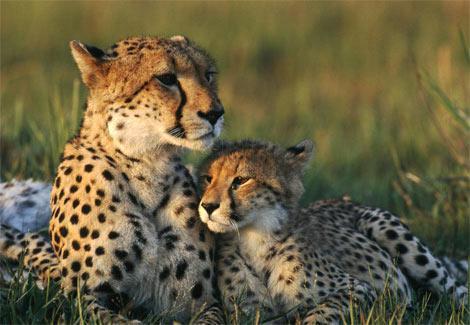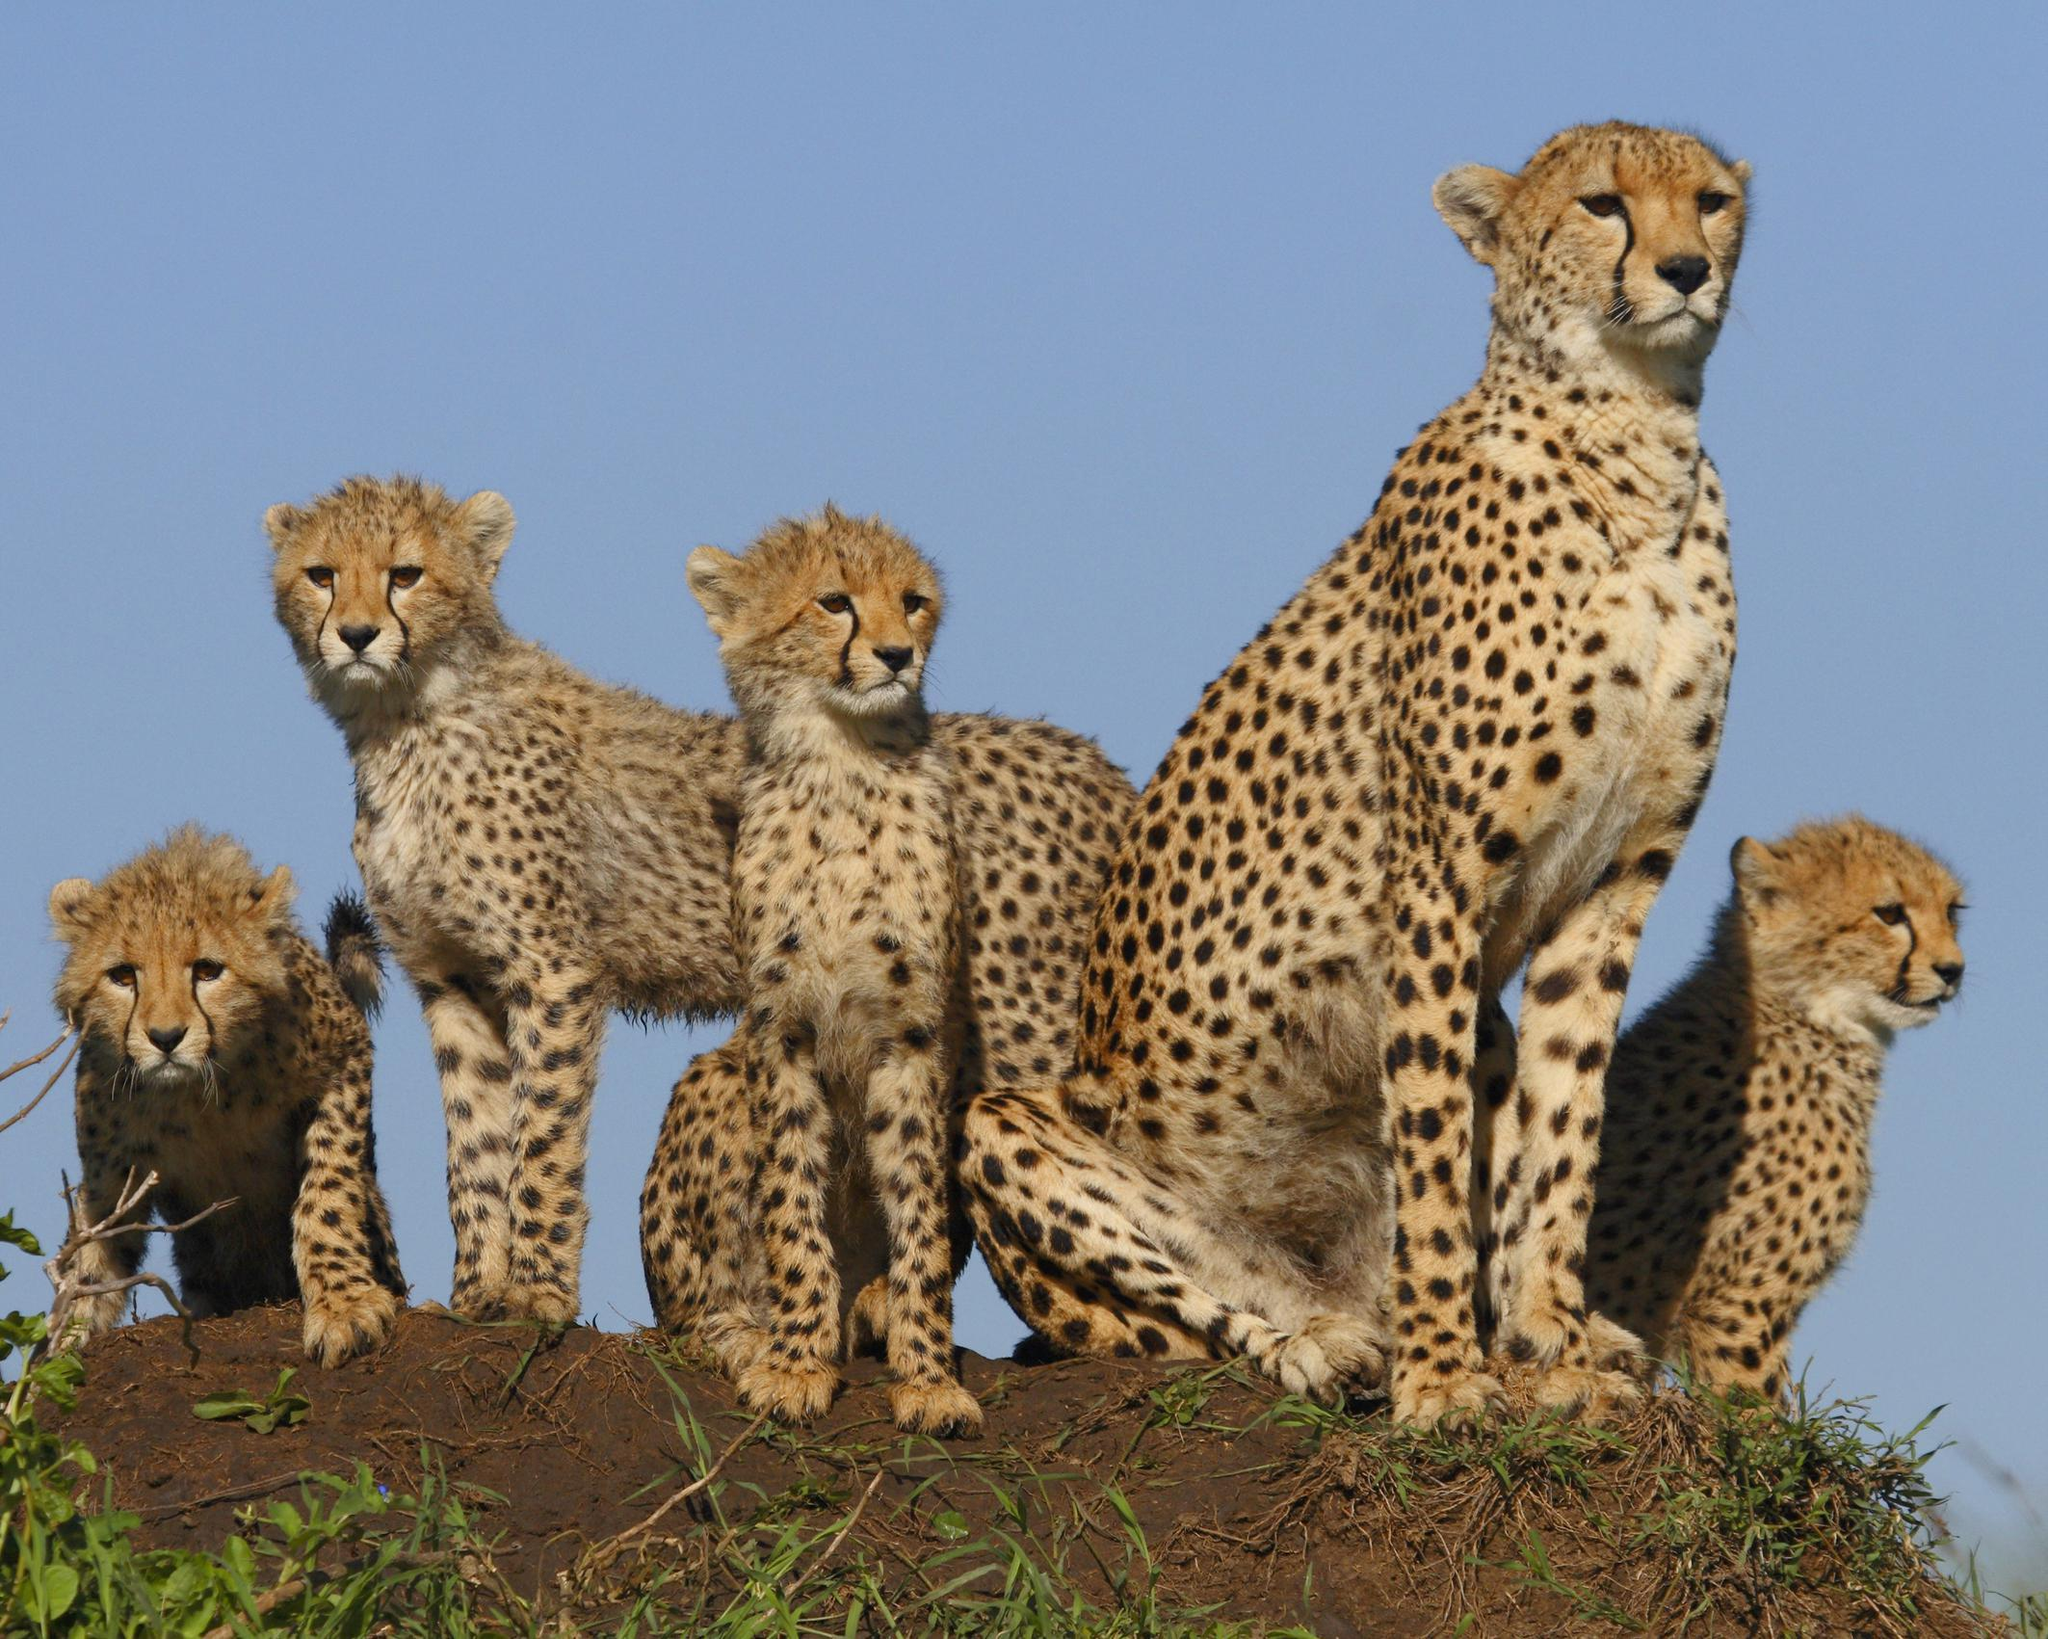The first image is the image on the left, the second image is the image on the right. Assess this claim about the two images: "There are five animals in the image on the right.". Correct or not? Answer yes or no. Yes. The first image is the image on the left, the second image is the image on the right. Analyze the images presented: Is the assertion "The left image contains more cheetahs than the right image." valid? Answer yes or no. No. 